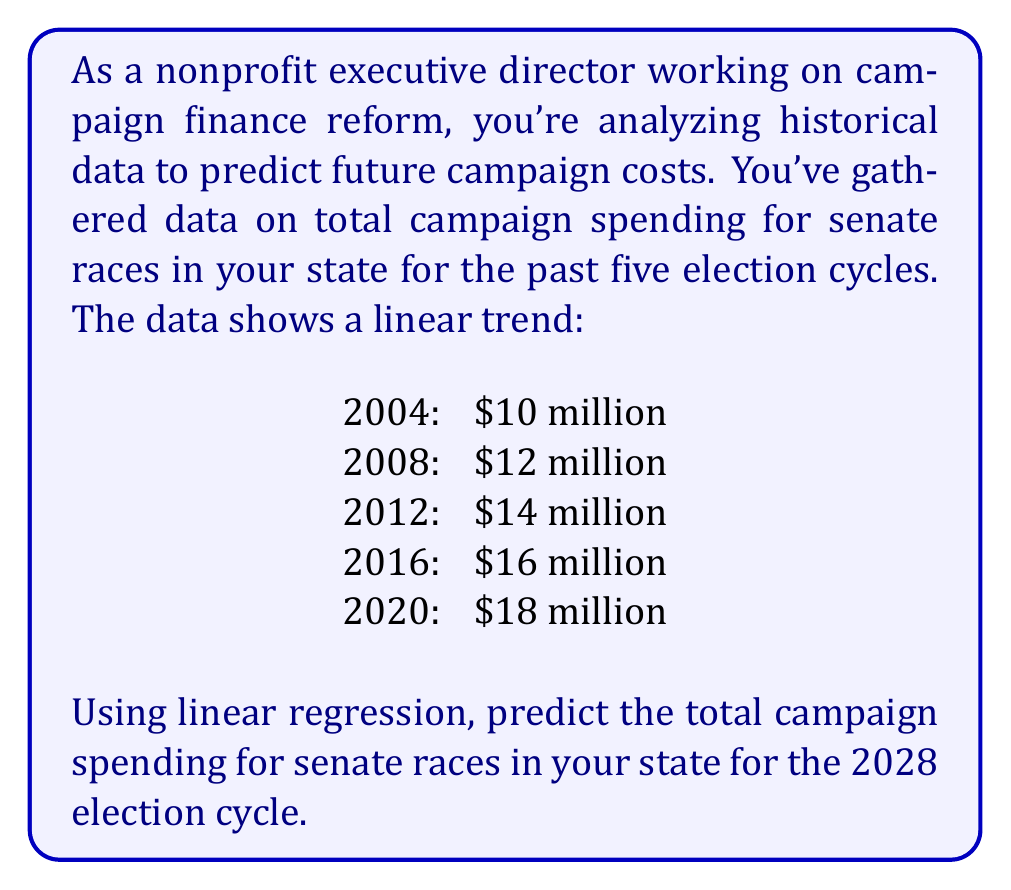Can you answer this question? To solve this problem, we'll use linear regression to find the line of best fit for the given data points and then use that line to predict the spending for 2028.

1. First, let's assign variables:
   $x$ = number of years since 2000
   $y$ = campaign spending in millions of dollars

2. Our data points are:
   (4, 10), (8, 12), (12, 14), (16, 16), (20, 18)

3. To find the line of best fit, we'll use the formula:
   $y = mx + b$
   where $m$ is the slope and $b$ is the y-intercept.

4. To calculate the slope $m$, we'll use the formula:
   $$m = \frac{\sum_{i=1}^{n} (x_i - \bar{x})(y_i - \bar{y})}{\sum_{i=1}^{n} (x_i - \bar{x})^2}$$

5. Calculate the means:
   $\bar{x} = \frac{4 + 8 + 12 + 16 + 20}{5} = 12$
   $\bar{y} = \frac{10 + 12 + 14 + 16 + 18}{5} = 14$

6. Calculate the numerator and denominator:
   Numerator: $\sum_{i=1}^{n} (x_i - \bar{x})(y_i - \bar{y}) = 80$
   Denominator: $\sum_{i=1}^{n} (x_i - \bar{x})^2 = 160$

7. Calculate the slope:
   $m = \frac{80}{160} = 0.5$

8. Use the point-slope form to find $b$:
   $14 = 0.5(12) + b$
   $b = 14 - 6 = 8$

9. Our line of best fit is:
   $y = 0.5x + 8$

10. To predict the spending for 2028, we need to find $y$ when $x = 28$ (2028 - 2000 = 28):
    $y = 0.5(28) + 8 = 14 + 8 = 22$

Therefore, the predicted campaign spending for senate races in 2028 is $22 million.
Answer: $22 million 